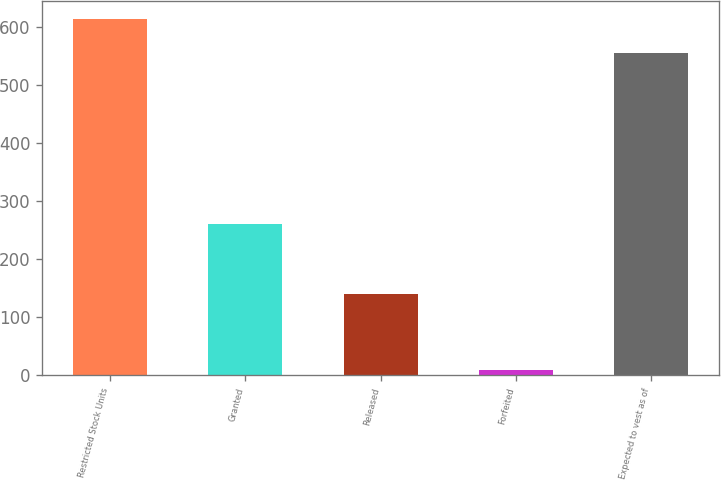Convert chart. <chart><loc_0><loc_0><loc_500><loc_500><bar_chart><fcel>Restricted Stock Units<fcel>Granted<fcel>Released<fcel>Forfeited<fcel>Expected to vest as of<nl><fcel>614<fcel>260<fcel>140<fcel>10<fcel>554.5<nl></chart> 